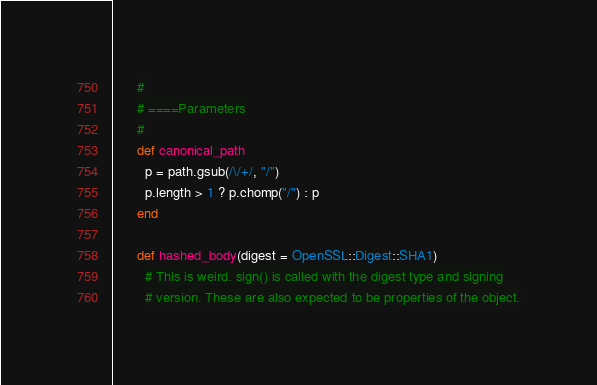<code> <loc_0><loc_0><loc_500><loc_500><_Ruby_>      #
      # ====Parameters
      #
      def canonical_path
        p = path.gsub(/\/+/, "/")
        p.length > 1 ? p.chomp("/") : p
      end

      def hashed_body(digest = OpenSSL::Digest::SHA1)
        # This is weird. sign() is called with the digest type and signing
        # version. These are also expected to be properties of the object.</code> 